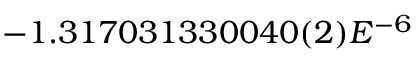Convert formula to latex. <formula><loc_0><loc_0><loc_500><loc_500>- 1 . 3 1 7 0 3 1 3 3 0 0 4 0 ( 2 ) E ^ { - 6 }</formula> 